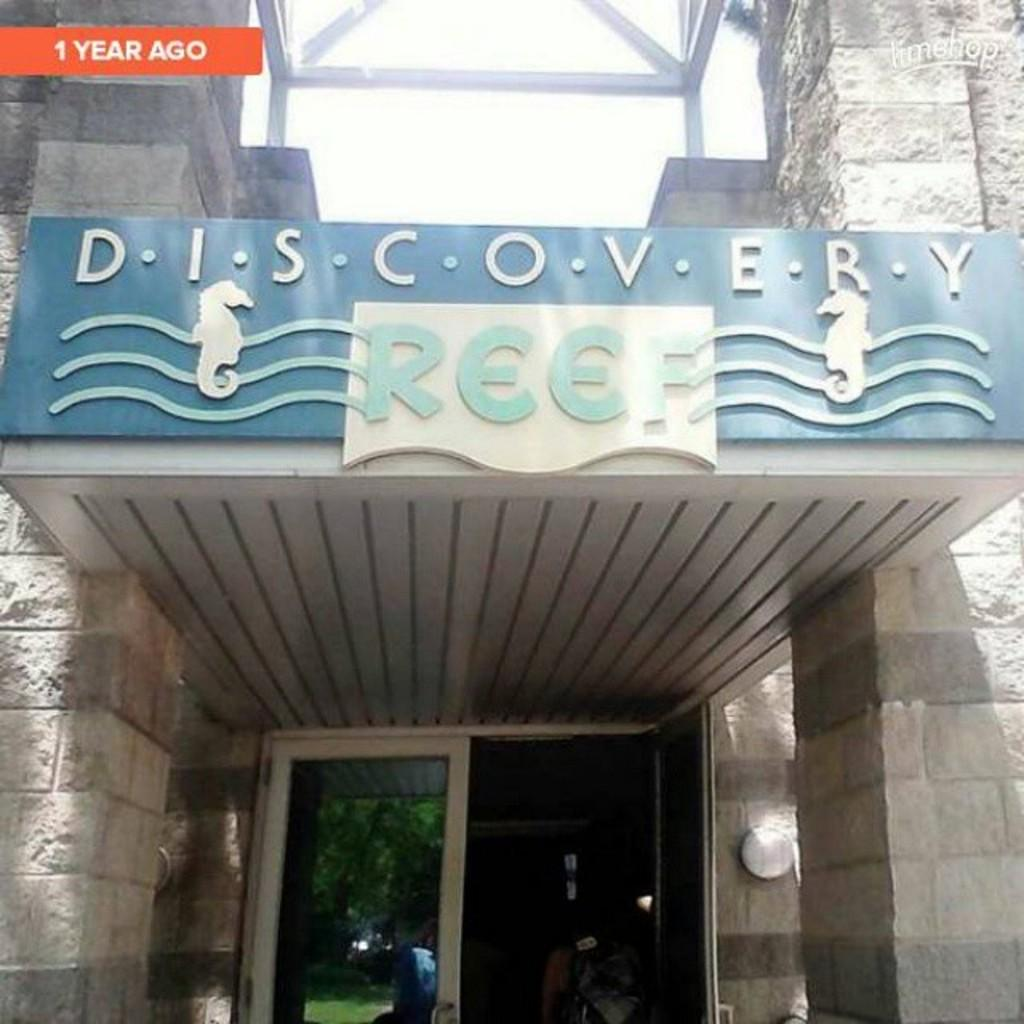What type of structure is visible in the image? There is a building in the image. What is attached to the wall inside the building? There is a board with text and images in the image. Where is the board located within the building? The board is hanging on a wall. Can you describe the people inside the building? There are people inside the building, but their specific actions or characteristics are not mentioned in the provided facts. What is the title of the locket hanging from the board in the image? There is no locket present in the image, so it is not possible to determine its title. 